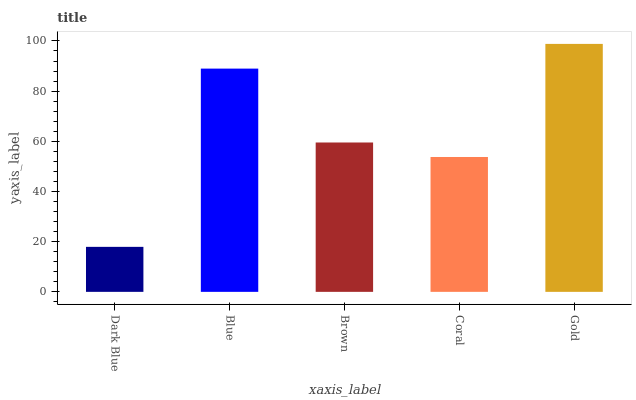Is Dark Blue the minimum?
Answer yes or no. Yes. Is Gold the maximum?
Answer yes or no. Yes. Is Blue the minimum?
Answer yes or no. No. Is Blue the maximum?
Answer yes or no. No. Is Blue greater than Dark Blue?
Answer yes or no. Yes. Is Dark Blue less than Blue?
Answer yes or no. Yes. Is Dark Blue greater than Blue?
Answer yes or no. No. Is Blue less than Dark Blue?
Answer yes or no. No. Is Brown the high median?
Answer yes or no. Yes. Is Brown the low median?
Answer yes or no. Yes. Is Blue the high median?
Answer yes or no. No. Is Coral the low median?
Answer yes or no. No. 